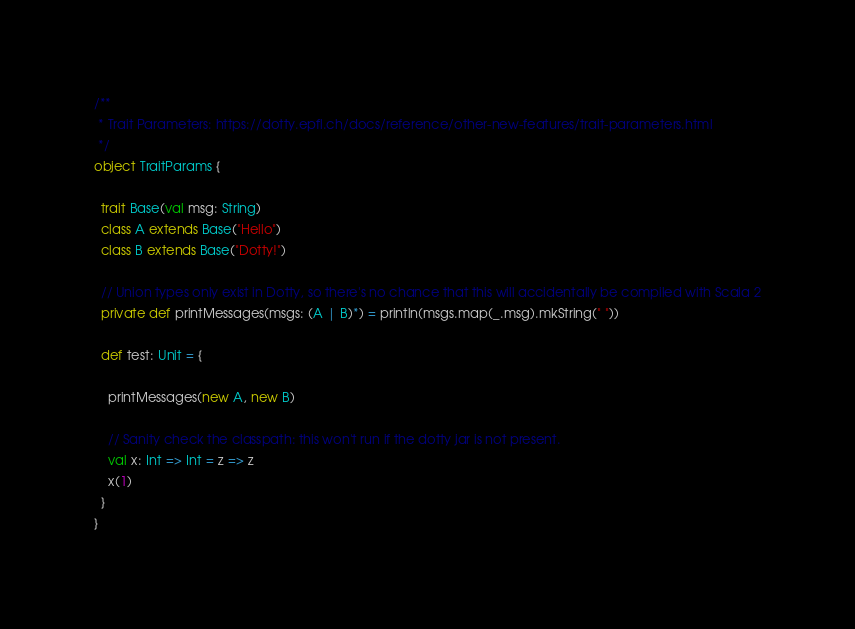Convert code to text. <code><loc_0><loc_0><loc_500><loc_500><_Scala_>/**
 * Trait Parameters: https://dotty.epfl.ch/docs/reference/other-new-features/trait-parameters.html
 */
object TraitParams {

  trait Base(val msg: String)
  class A extends Base("Hello")
  class B extends Base("Dotty!")

  // Union types only exist in Dotty, so there's no chance that this will accidentally be compiled with Scala 2
  private def printMessages(msgs: (A | B)*) = println(msgs.map(_.msg).mkString(" "))

  def test: Unit = {

    printMessages(new A, new B)

    // Sanity check the classpath: this won't run if the dotty jar is not present.
    val x: Int => Int = z => z
    x(1)
  }
}
</code> 